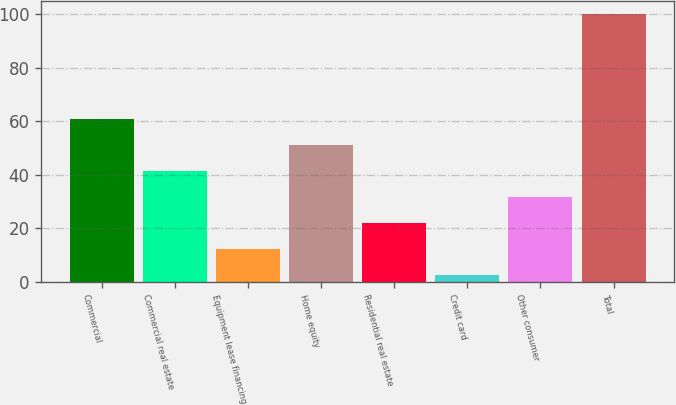Convert chart to OTSL. <chart><loc_0><loc_0><loc_500><loc_500><bar_chart><fcel>Commercial<fcel>Commercial real estate<fcel>Equipment lease financing<fcel>Home equity<fcel>Residential real estate<fcel>Credit card<fcel>Other consumer<fcel>Total<nl><fcel>60.96<fcel>41.44<fcel>12.16<fcel>51.2<fcel>21.92<fcel>2.4<fcel>31.68<fcel>100<nl></chart> 